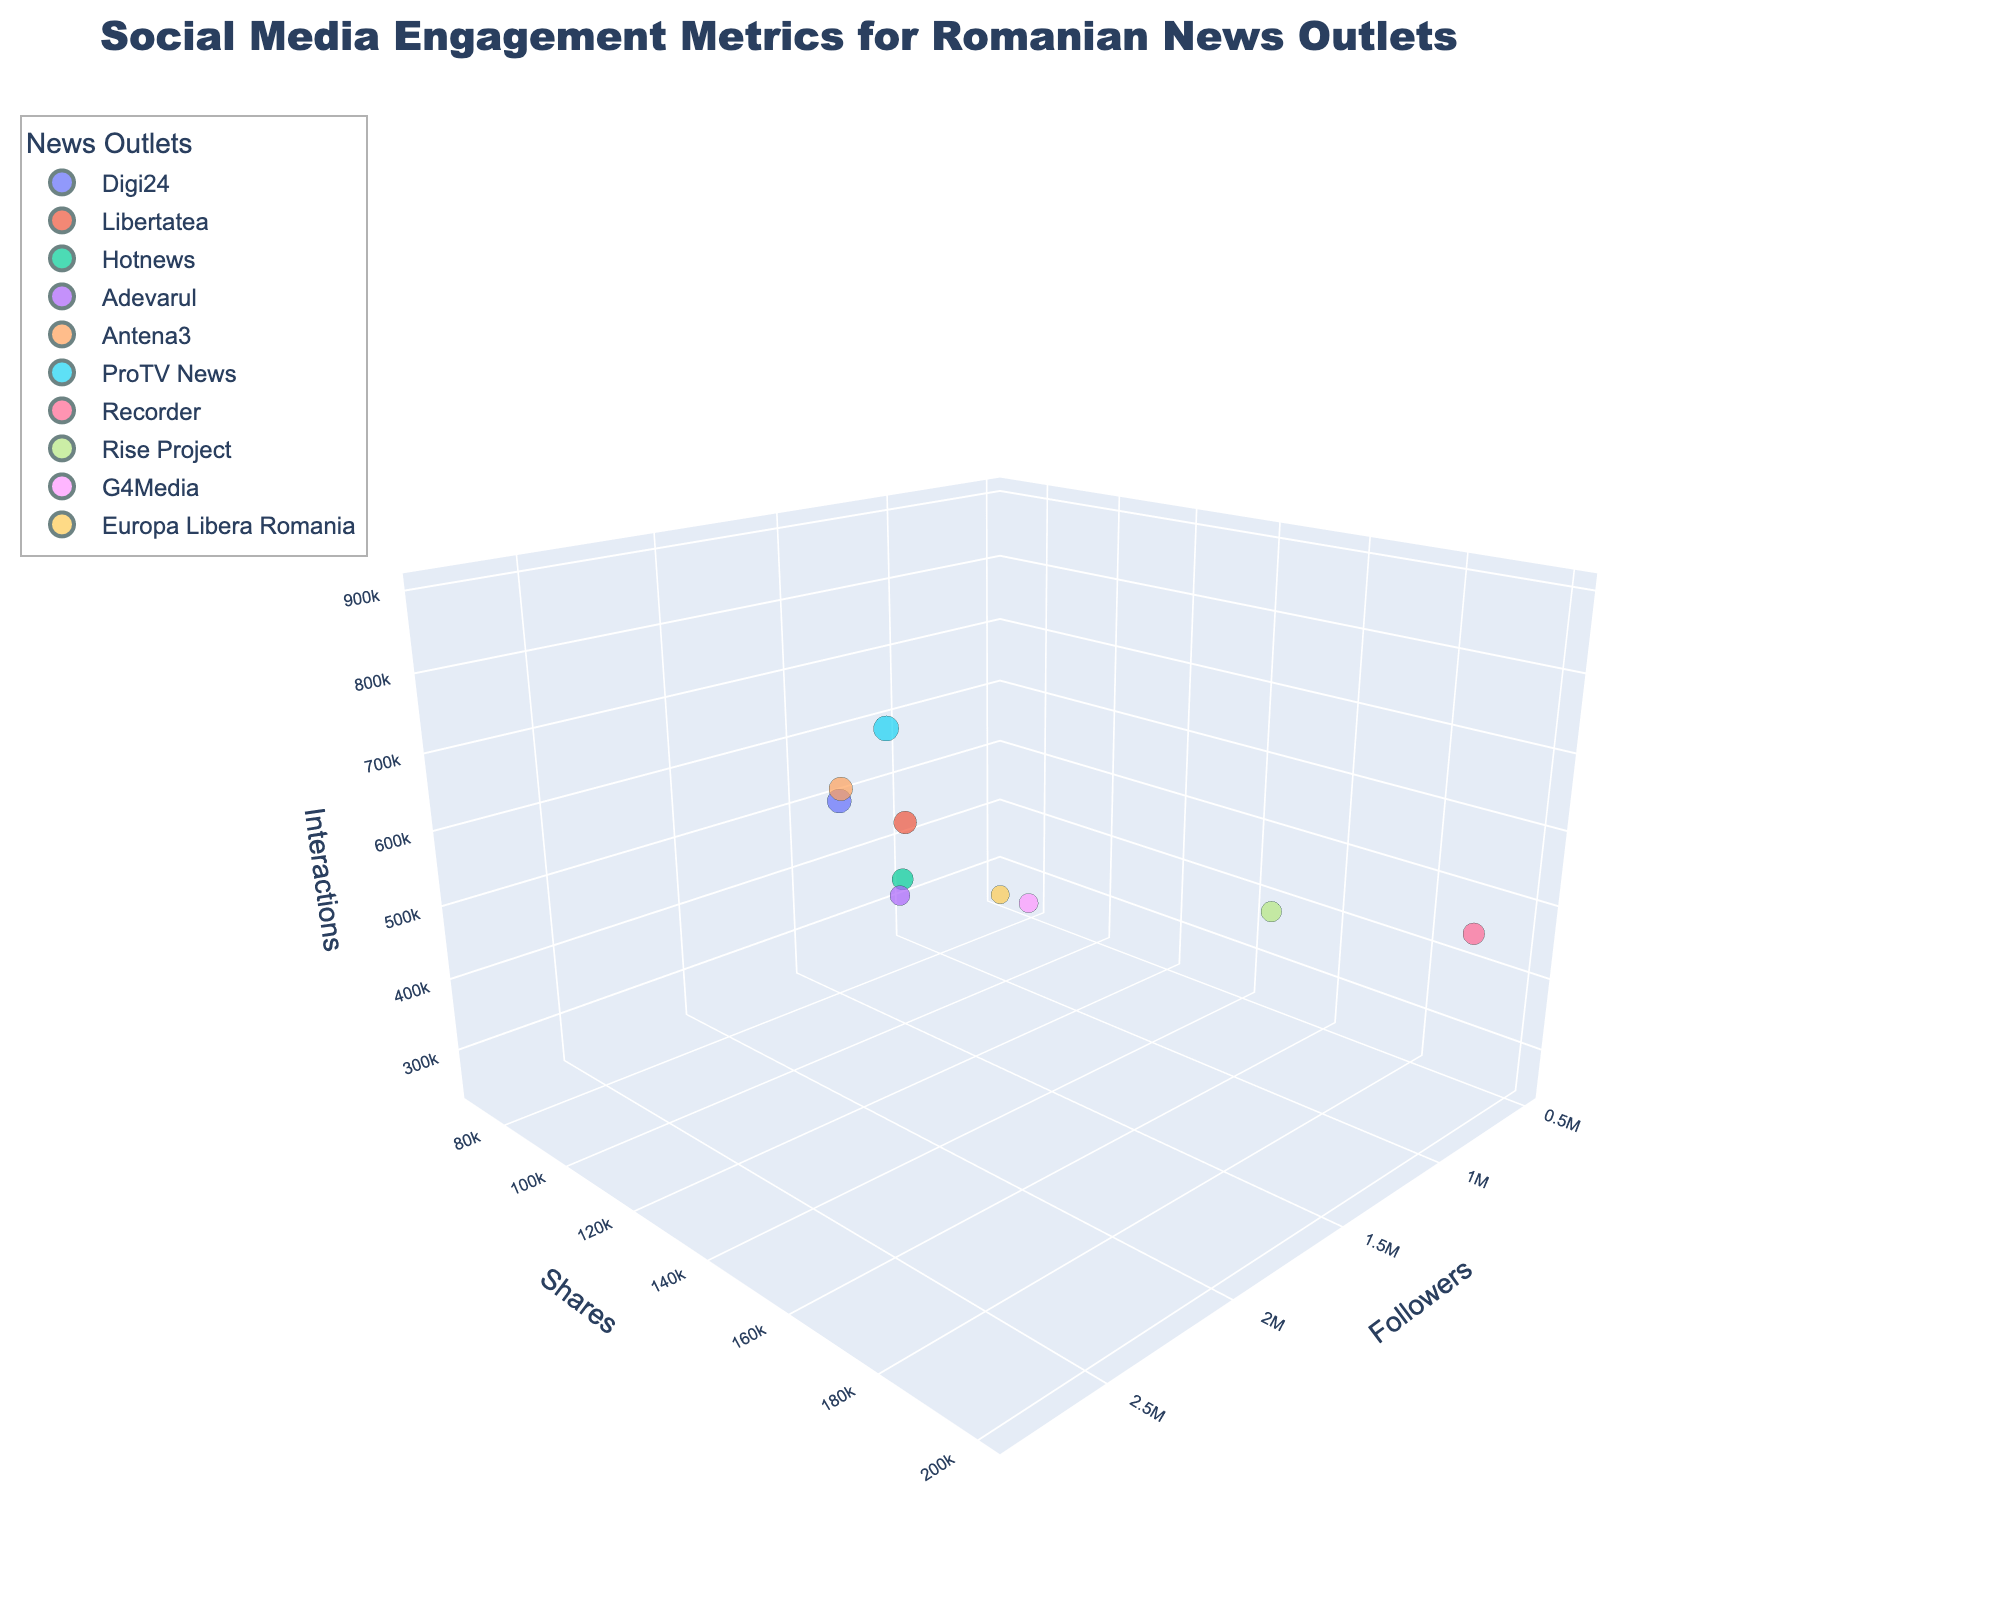How many news outlets are represented in the chart? To find the number of news outlets, count the distinct data points or colors representing each outlet in the chart. Since each outlet is uniquely colored and labeled, you can identify them easily.
Answer: 10 What is the title of the chart? The title is usually displayed prominently at the top of the chart.
Answer: Social Media Engagement Metrics for Romanian News Outlets Which news outlet has the highest number of followers? Inspect the x-axis (Followers) and identify the data point with the highest value on this axis.
Answer: ProTV News Which news outlet has the lowest number of shares? Look at the y-axis (Shares) and determine the data point with the smallest value on this axis.
Answer: Europa Libera Romania How many news outlets have more than 1,500,000 followers? Examine the x-axis (Followers) and count the data points whose x-values exceed 1,500,000.
Answer: 4 Which news outlet has the largest bubble size? The bubble size represents the number of interactions. Identify the largest bubble visually.
Answer: ProTV News Which two news outlets have the closest number of interactions? Look at the z-axis (Interactions) and identify two bubbles closely positioned or having similar z-values.
Answer: Adevarul and G4Media Among the news outlets with over 1,500,000 followers, which has the least shares? Filter the news outlets with more than 1,500,000 followers and compare their y-values (Shares).
Answer: Hotnews What's the average number of shares for all news outlets? Sum up the shares of all outlets and divide by the number of outlets: (150000 + 120000 + 100000 + 80000 + 130000 + 180000 + 200000 + 150000 + 90000 + 70000) / 10
Answer: 127000 Do any news outlets have an equal number of shares and interactions? Compare the y-values (Shares) and z-values (Interactions) for each news outlet to see if any are equal.
Answer: No 